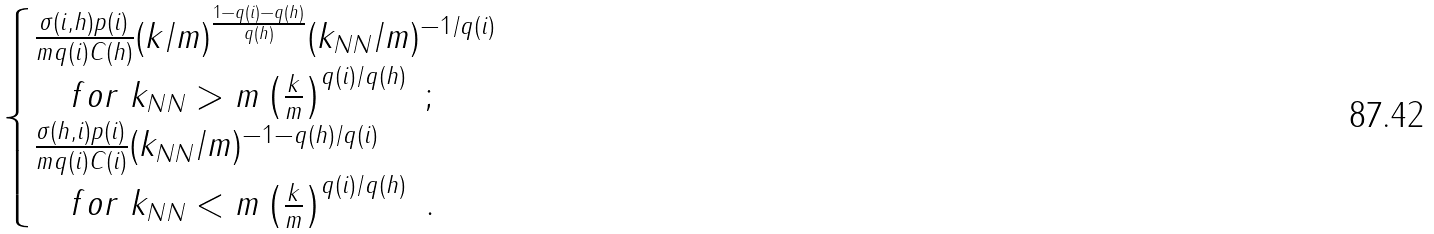<formula> <loc_0><loc_0><loc_500><loc_500>\begin{cases} \frac { \sigma ( i , h ) p ( i ) } { m q ( i ) C ( h ) } ( k / m ) ^ { \frac { 1 - q ( i ) - q ( h ) } { q ( h ) } } ( k _ { N N } / m ) ^ { - 1 / q ( i ) } \\ \quad f o r \ k _ { N N } > m \left ( \frac { k } { m } \right ) ^ { q ( i ) / q ( h ) } \ ; \ \\ \frac { \sigma ( h , i ) p ( i ) } { m q ( i ) C ( i ) } ( k _ { N N } / m ) ^ { - 1 - q ( h ) / q ( i ) } \\ \quad f o r \ k _ { N N } < m \left ( \frac { k } { m } \right ) ^ { q ( i ) / q ( h ) } \ . \ \end{cases}</formula> 